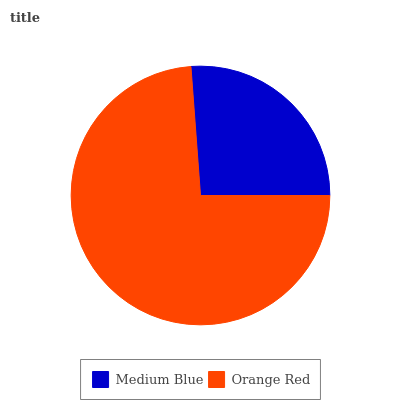Is Medium Blue the minimum?
Answer yes or no. Yes. Is Orange Red the maximum?
Answer yes or no. Yes. Is Orange Red the minimum?
Answer yes or no. No. Is Orange Red greater than Medium Blue?
Answer yes or no. Yes. Is Medium Blue less than Orange Red?
Answer yes or no. Yes. Is Medium Blue greater than Orange Red?
Answer yes or no. No. Is Orange Red less than Medium Blue?
Answer yes or no. No. Is Orange Red the high median?
Answer yes or no. Yes. Is Medium Blue the low median?
Answer yes or no. Yes. Is Medium Blue the high median?
Answer yes or no. No. Is Orange Red the low median?
Answer yes or no. No. 